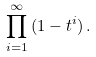Convert formula to latex. <formula><loc_0><loc_0><loc_500><loc_500>\prod _ { i = 1 } ^ { \infty } \, ( 1 - t ^ { i } ) \, .</formula> 